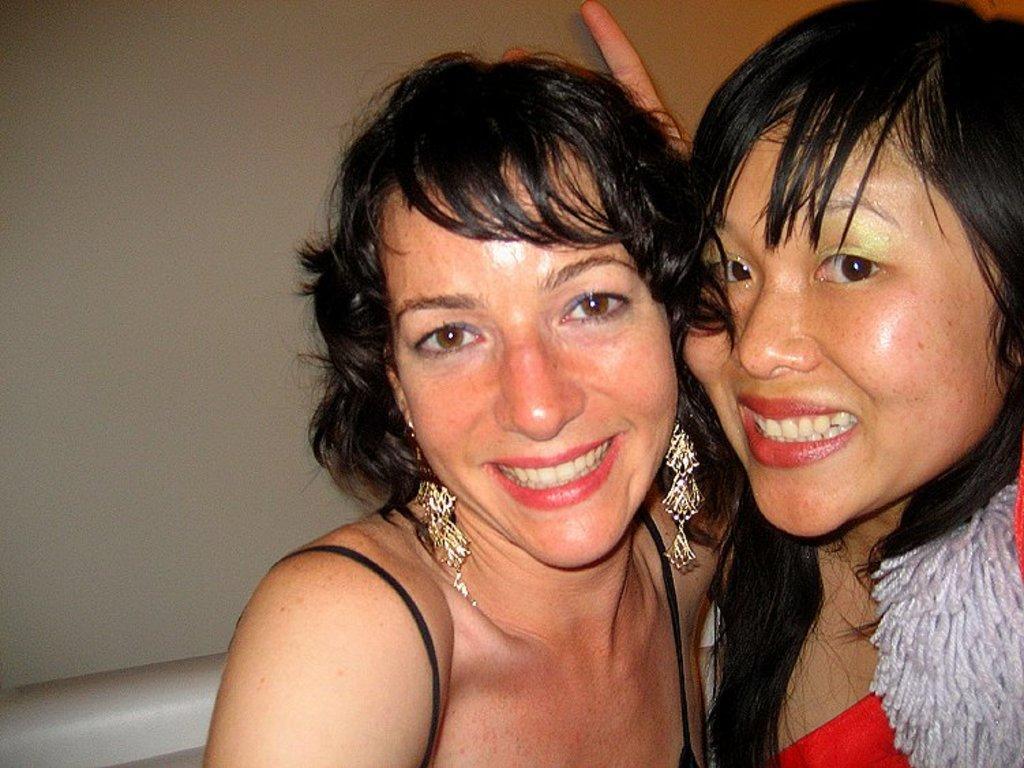Please provide a concise description of this image. In this image we can see two persons. There is an object at the left bottom most of the image. 